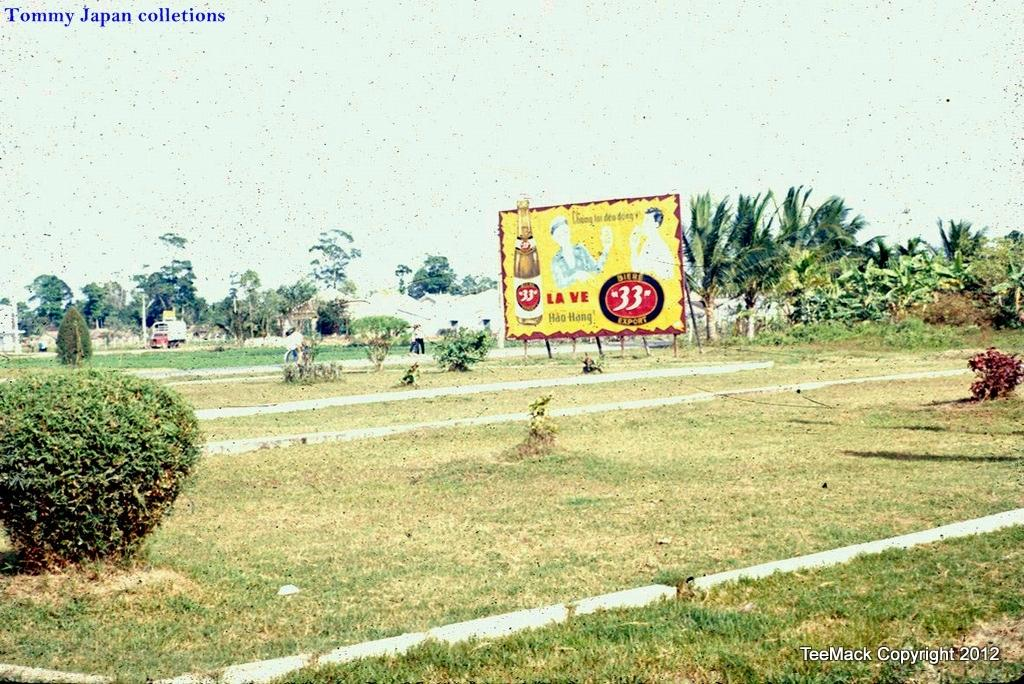What type of vegetation is in the foreground of the image? There are grasses and plants in the foreground of the image. What can be seen in the background of the image? There are trees and a hoarding in the background of the image. Are there any people visible in the image? Yes, there are people visible in the image. What part of the natural environment is visible in the image? The sky is visible in the image. Can you hear the whistle of the fairies in the image? There are no fairies or whistles present in the image. Who is the aunt in the image? There is no mention of an aunt in the image or the provided facts. 